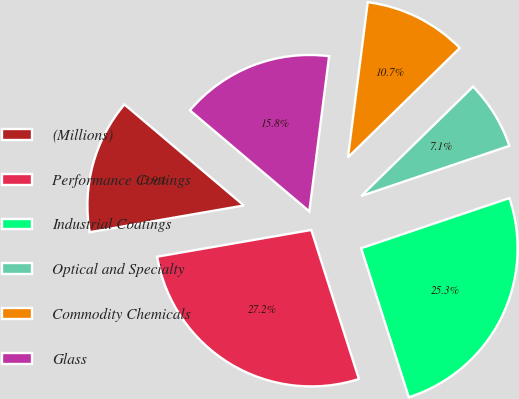Convert chart. <chart><loc_0><loc_0><loc_500><loc_500><pie_chart><fcel>(Millions)<fcel>Performance Coatings<fcel>Industrial Coatings<fcel>Optical and Specialty<fcel>Commodity Chemicals<fcel>Glass<nl><fcel>13.91%<fcel>27.19%<fcel>25.27%<fcel>7.13%<fcel>10.66%<fcel>15.84%<nl></chart> 